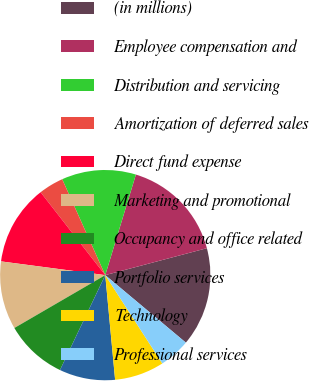<chart> <loc_0><loc_0><loc_500><loc_500><pie_chart><fcel>(in millions)<fcel>Employee compensation and<fcel>Distribution and servicing<fcel>Amortization of deferred sales<fcel>Direct fund expense<fcel>Marketing and promotional<fcel>Occupancy and office related<fcel>Portfolio services<fcel>Technology<fcel>Professional services<nl><fcel>15.22%<fcel>16.17%<fcel>11.42%<fcel>3.83%<fcel>12.37%<fcel>10.47%<fcel>9.53%<fcel>8.58%<fcel>7.63%<fcel>4.78%<nl></chart> 